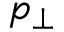Convert formula to latex. <formula><loc_0><loc_0><loc_500><loc_500>p _ { \perp }</formula> 